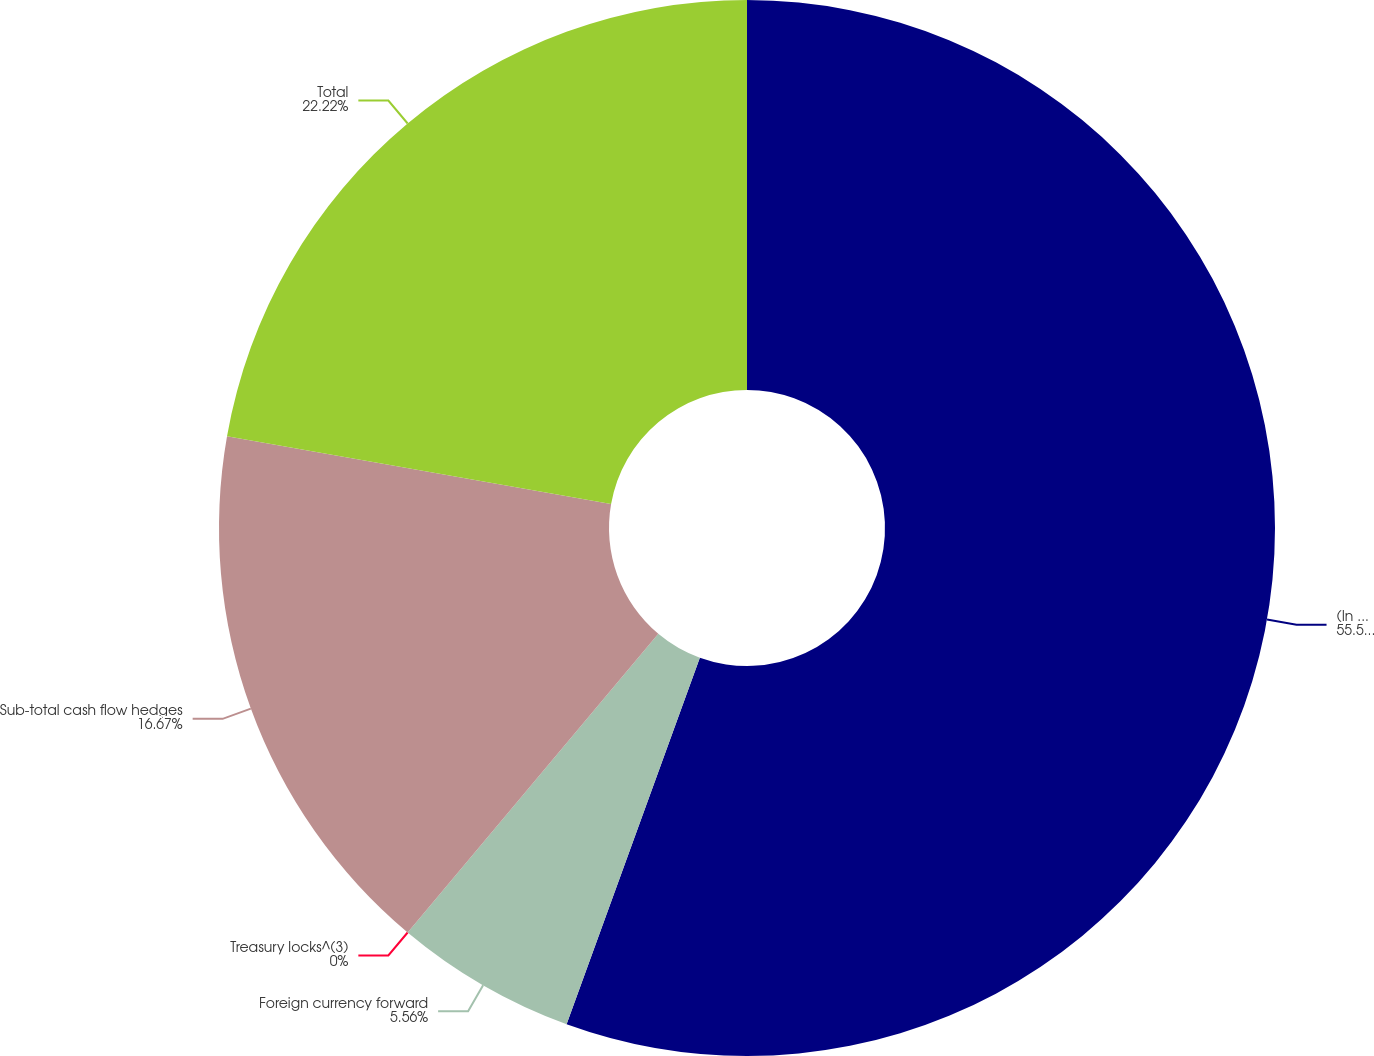Convert chart. <chart><loc_0><loc_0><loc_500><loc_500><pie_chart><fcel>(In millions)<fcel>Foreign currency forward<fcel>Treasury locks^(3)<fcel>Sub-total cash flow hedges<fcel>Total<nl><fcel>55.55%<fcel>5.56%<fcel>0.0%<fcel>16.67%<fcel>22.22%<nl></chart> 